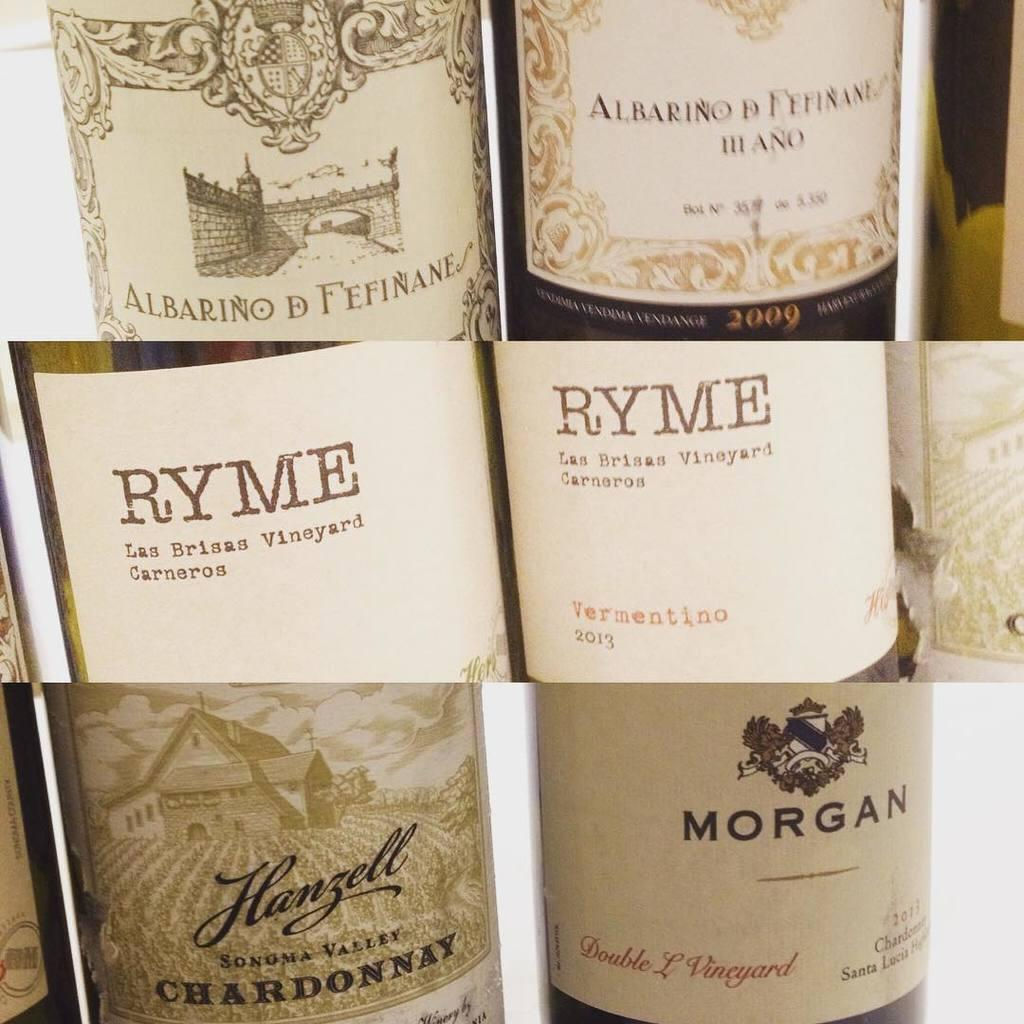<image>
Render a clear and concise summary of the photo. Several bottles of wines by Ryme and Morgan are shown. 